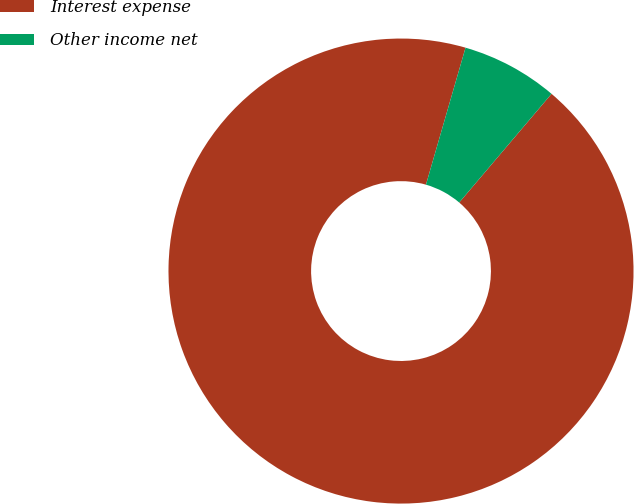<chart> <loc_0><loc_0><loc_500><loc_500><pie_chart><fcel>Interest expense<fcel>Other income net<nl><fcel>93.27%<fcel>6.73%<nl></chart> 